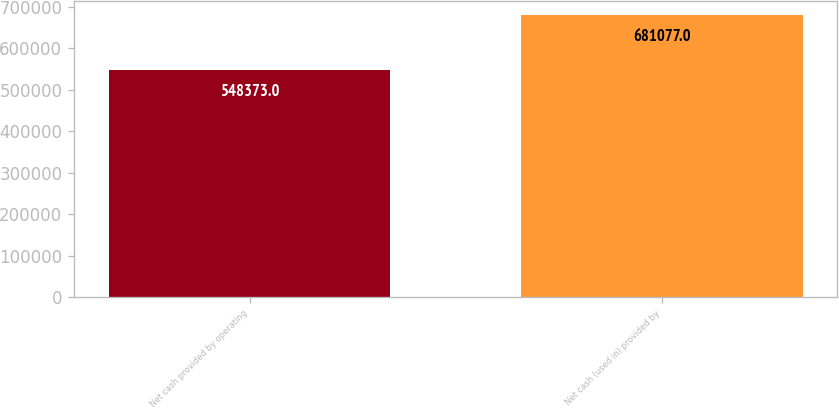Convert chart to OTSL. <chart><loc_0><loc_0><loc_500><loc_500><bar_chart><fcel>Net cash provided by operating<fcel>Net cash (used in) provided by<nl><fcel>548373<fcel>681077<nl></chart> 